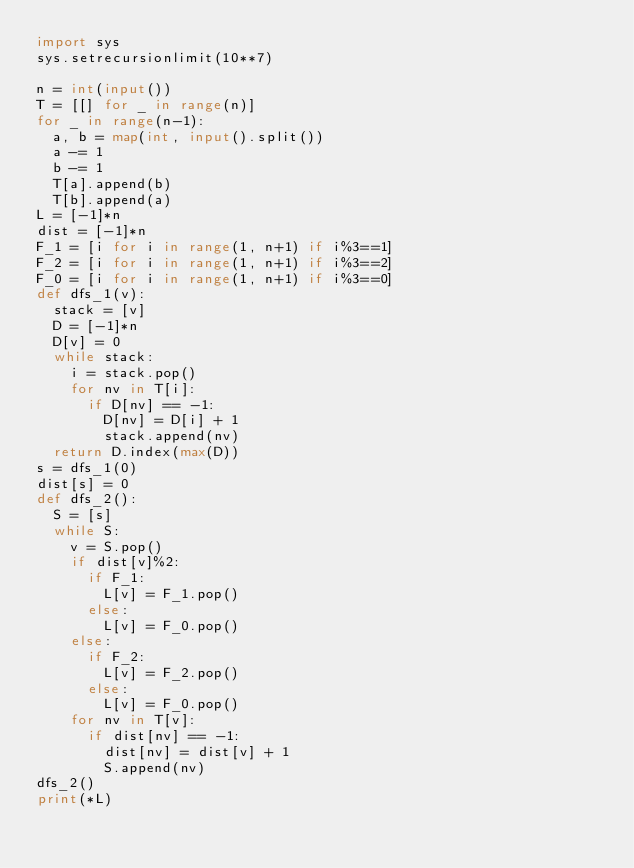<code> <loc_0><loc_0><loc_500><loc_500><_Python_>import sys
sys.setrecursionlimit(10**7)

n = int(input())
T = [[] for _ in range(n)]
for _ in range(n-1):
  a, b = map(int, input().split())
  a -= 1
  b -= 1
  T[a].append(b)
  T[b].append(a)
L = [-1]*n
dist = [-1]*n
F_1 = [i for i in range(1, n+1) if i%3==1]
F_2 = [i for i in range(1, n+1) if i%3==2]
F_0 = [i for i in range(1, n+1) if i%3==0]
def dfs_1(v):
  stack = [v]
  D = [-1]*n
  D[v] = 0
  while stack:
    i = stack.pop()
    for nv in T[i]:
      if D[nv] == -1:
        D[nv] = D[i] + 1
        stack.append(nv)
  return D.index(max(D))
s = dfs_1(0)
dist[s] = 0
def dfs_2():
  S = [s]
  while S:
    v = S.pop()
    if dist[v]%2:
      if F_1:
        L[v] = F_1.pop()
      else:
        L[v] = F_0.pop()
    else:
      if F_2:
        L[v] = F_2.pop()
      else:
        L[v] = F_0.pop()
    for nv in T[v]:
      if dist[nv] == -1:
        dist[nv] = dist[v] + 1
        S.append(nv)
dfs_2()
print(*L)</code> 